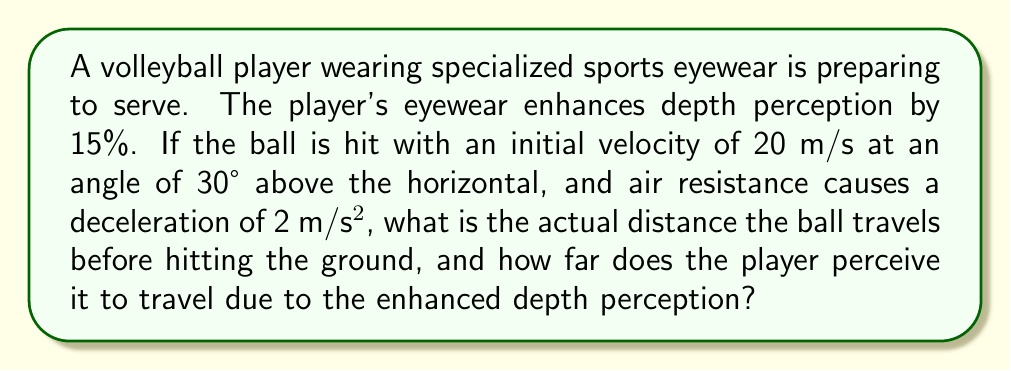Solve this math problem. Let's break this down step-by-step:

1) First, we need to calculate the time the ball is in the air. The vertical motion is governed by the equation:

   $$y = v_0\sin\theta \cdot t - \frac{1}{2}gt^2$$

   Where $v_0 = 20$ m/s, $\theta = 30°$, and $g = 9.8$ m/s².

2) At the highest point, $\frac{dy}{dt} = 0$, so:

   $$v_0\sin\theta - gt = 0$$
   $$t = \frac{v_0\sin\theta}{g} = \frac{20 \cdot \sin30°}{9.8} \approx 1.02 \text{ s}$$

3) The total time in the air is twice this: $t_{total} \approx 2.04 \text{ s}$

4) Now, for the horizontal distance, we need to consider air resistance:

   $$x = v_0\cos\theta \cdot t - \frac{1}{2}at^2$$

   Where $a = 2$ m/s² (deceleration due to air resistance)

5) Plugging in our values:

   $$x = 20\cos30° \cdot 2.04 - \frac{1}{2} \cdot 2 \cdot 2.04^2 \approx 31.85 \text{ m}$$

6) This is the actual distance. The perceived distance due to the 15% enhancement in depth perception would be:

   $$31.85 \cdot 1.15 \approx 36.63 \text{ m}$$
Answer: Actual distance: 31.85 m, Perceived distance: 36.63 m 